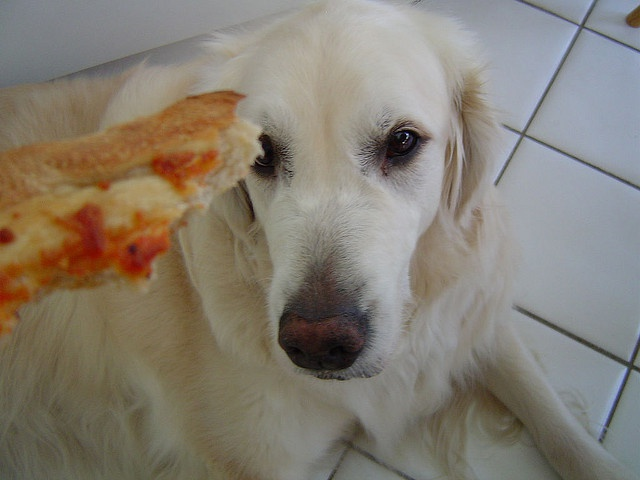Describe the objects in this image and their specific colors. I can see dog in gray and darkgray tones and pizza in gray, olive, tan, and maroon tones in this image. 